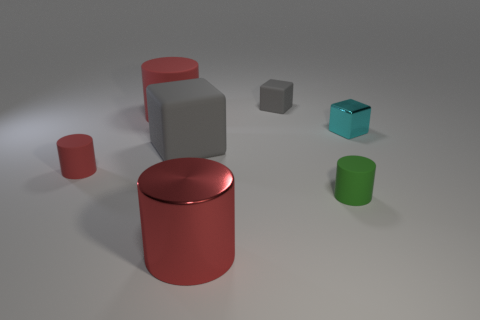How many tiny matte blocks have the same color as the tiny shiny object?
Offer a terse response. 0. There is a big thing that is made of the same material as the tiny cyan object; what shape is it?
Ensure brevity in your answer.  Cylinder. There is a rubber cylinder that is behind the tiny cyan metal object; how big is it?
Your answer should be compact. Large. Are there the same number of big gray matte blocks that are to the right of the tiny metal object and matte cubes that are left of the small gray matte object?
Keep it short and to the point. No. There is a rubber cylinder to the right of the gray object right of the red thing that is in front of the tiny green rubber cylinder; what is its color?
Your answer should be very brief. Green. What number of matte cylinders are in front of the cyan shiny object and left of the shiny cylinder?
Keep it short and to the point. 1. There is a small rubber thing on the left side of the small gray rubber block; does it have the same color as the shiny object that is in front of the tiny red object?
Keep it short and to the point. Yes. There is another gray rubber thing that is the same shape as the small gray thing; what size is it?
Your answer should be compact. Large. There is a metallic cylinder; are there any big red cylinders left of it?
Give a very brief answer. Yes. Is the number of large gray objects behind the green object the same as the number of tiny green matte cylinders?
Make the answer very short. Yes. 